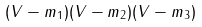<formula> <loc_0><loc_0><loc_500><loc_500>( V - m _ { 1 } ) ( V - m _ { 2 } ) ( V - m _ { 3 } ) \quad</formula> 